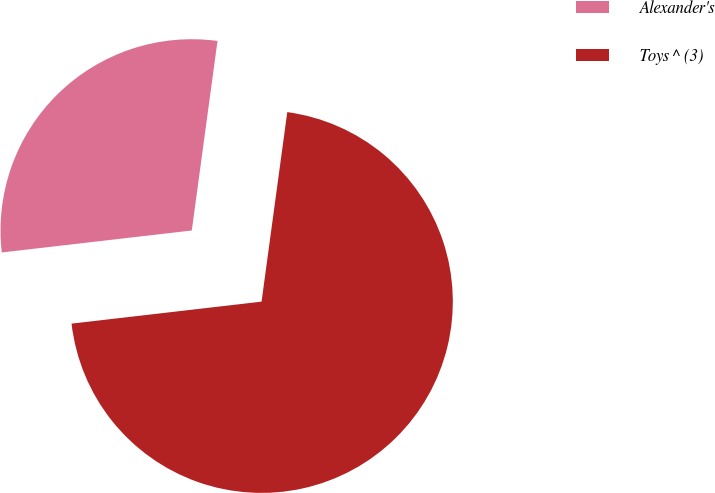<chart> <loc_0><loc_0><loc_500><loc_500><pie_chart><fcel>Alexander's<fcel>Toys ^ (3)<nl><fcel>28.98%<fcel>71.02%<nl></chart> 